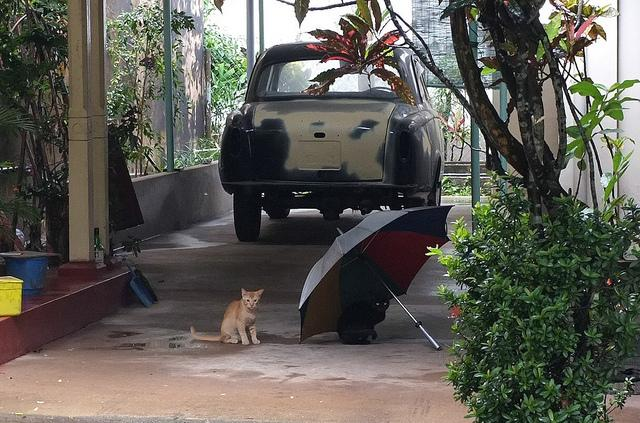What is under the umbrella?

Choices:
A) baby
B) black cat
C) old woman
D) old man black cat 